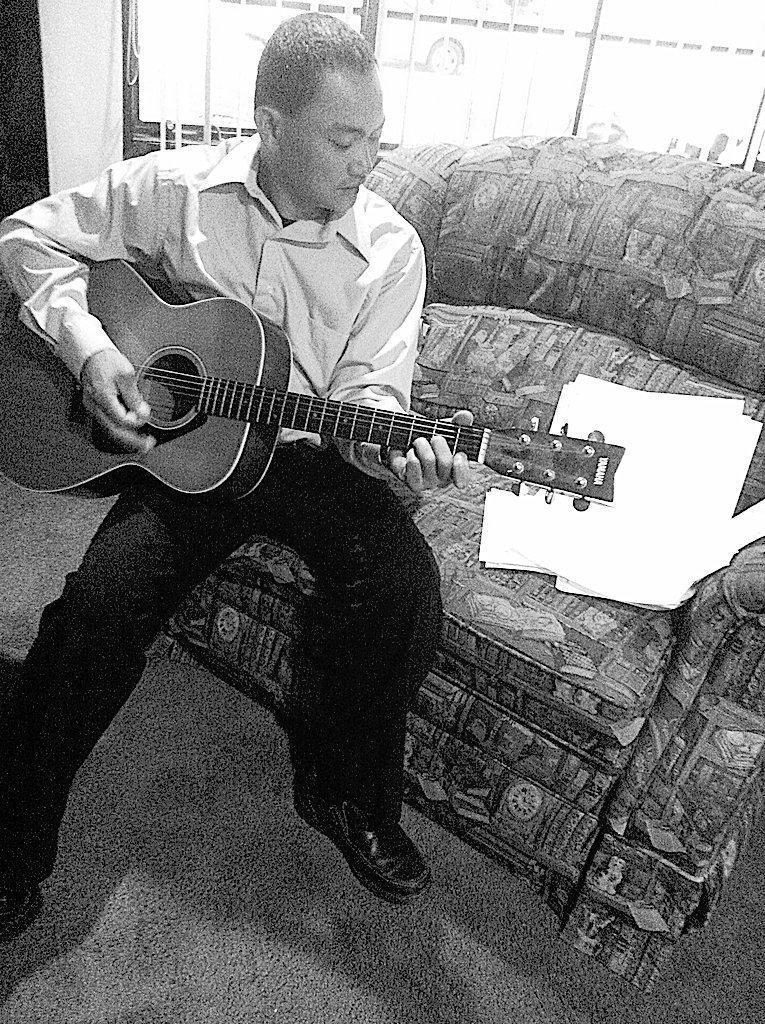Describe this image in one or two sentences. there is a person sitting on the sofa and playing guitar. 